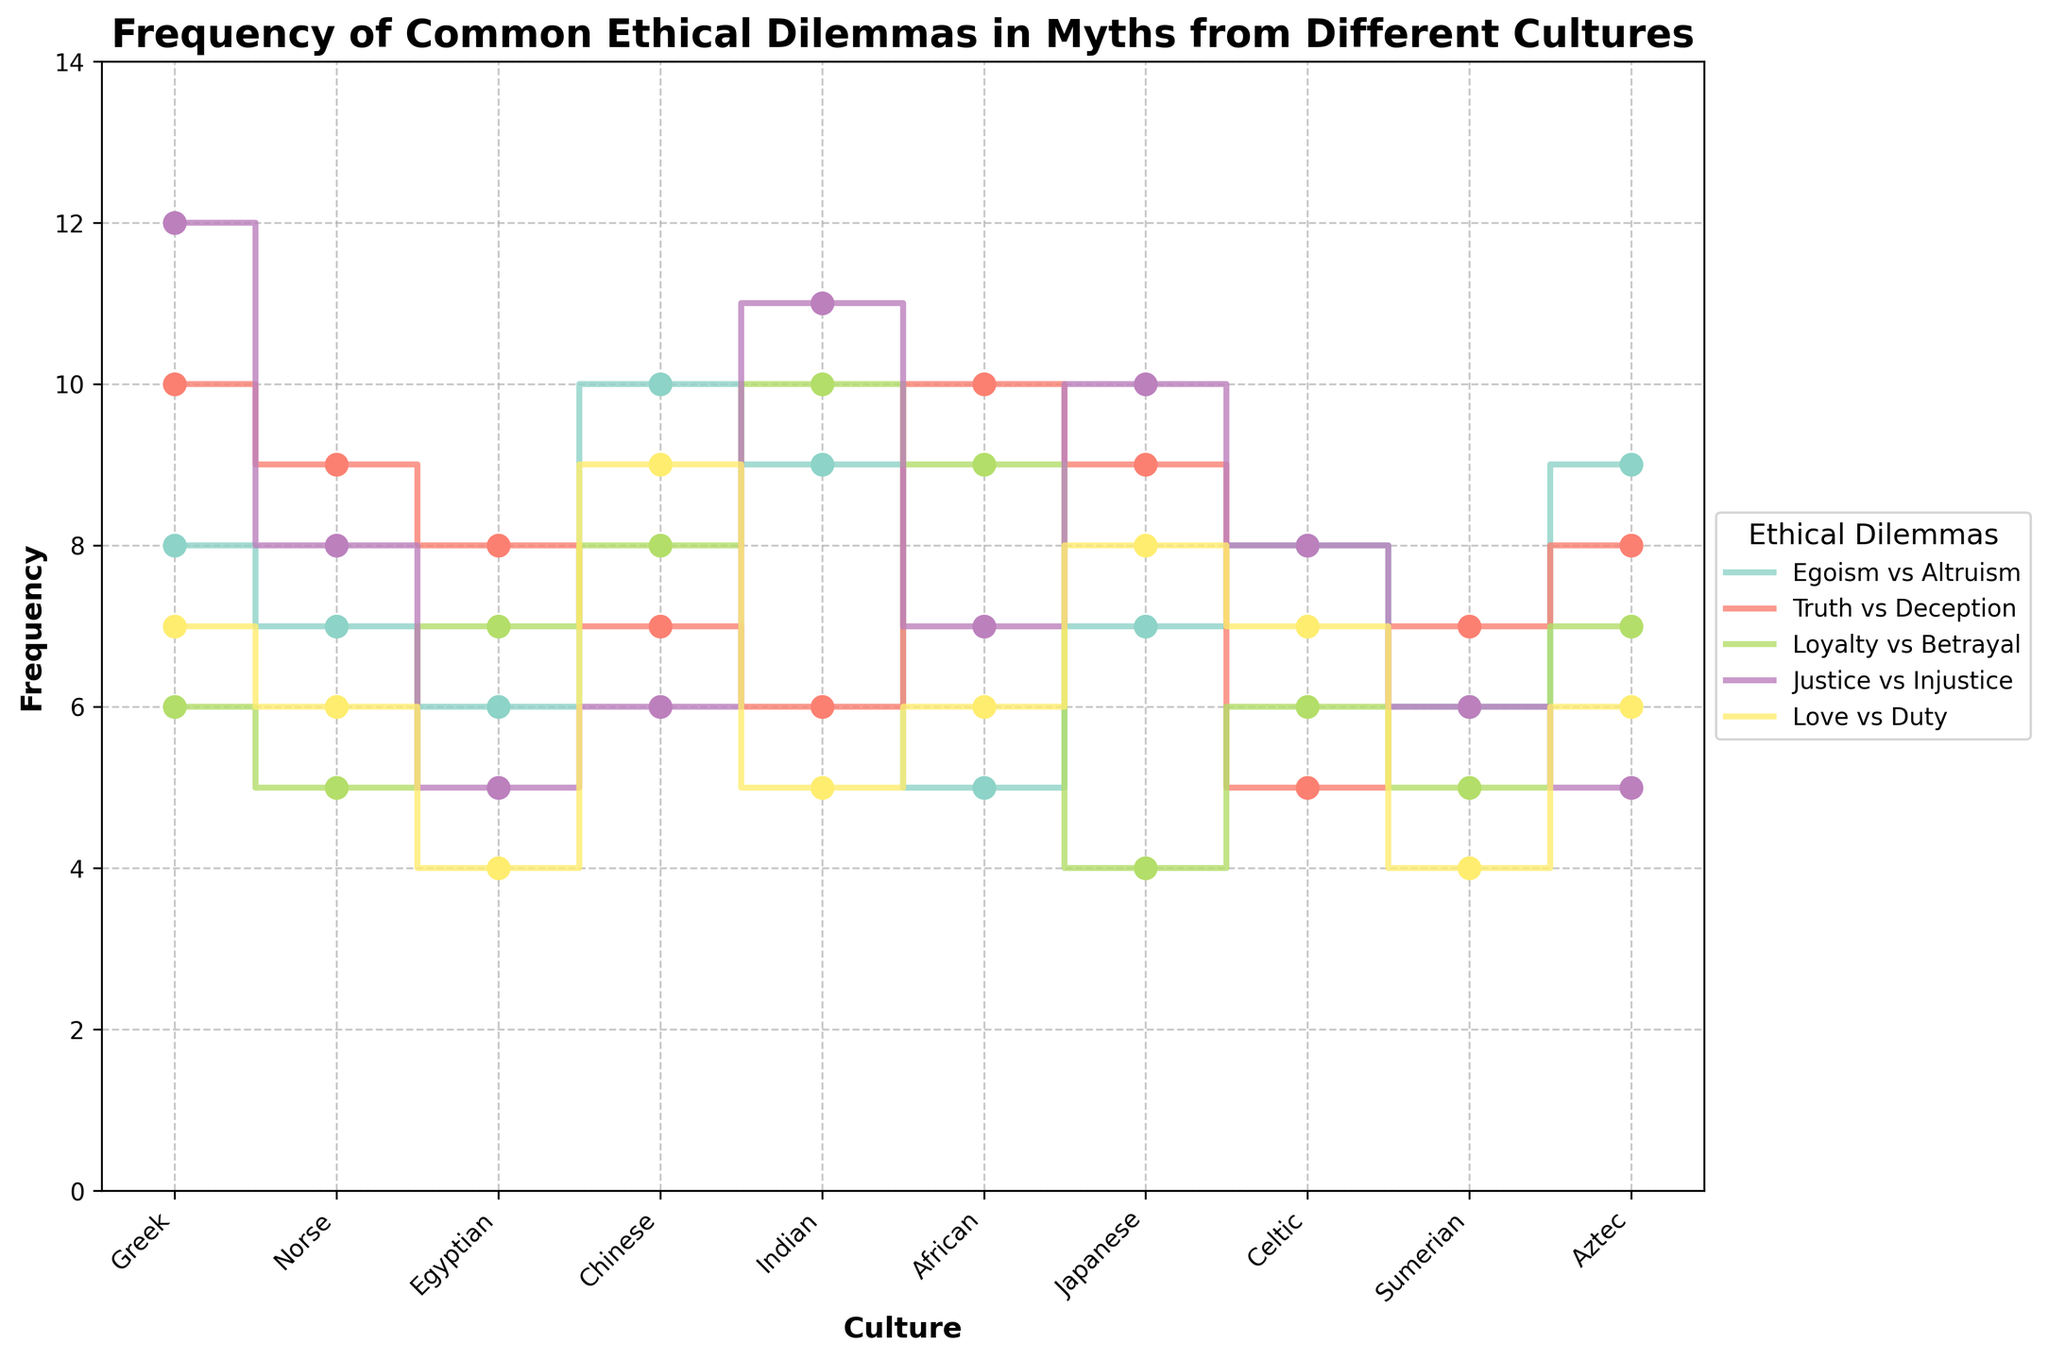What is the title of the figure? The title is written at the top of the figure. It summarizes the content and context of the data being visualized.
Answer: Frequency of Common Ethical Dilemmas in Myths from Different Cultures Which culture has the highest frequency of the "Justice vs Injustice" dilemma? Identify the highest point in the "Justice vs Injustice" (blue line) and note the corresponding culture on the x-axis. The highest frequency is at Greek culture.
Answer: Greek How many ethical dilemmas are plotted in the figure? There are distinct colored lines for each ethical dilemma, and each one is labeled. Count the different labels.
Answer: 5 What is the total frequency of all dilemmas for the Chinese culture? Sum the frequencies of all dilemmas for the Chinese culture: Egoism vs Altruism (10), Truth vs Deception (7), Loyalty vs Betrayal (8), Justice vs Injustice (6), Love vs Duty (9). 10+7+8+6+9 = 40.
Answer: 40 Which dilemma appears least frequently in Egyptian myths? Identify the lowest point among all the dilemmas for Egyptian culture. "Love vs Duty" (red line) has the lowest value.
Answer: Love vs Duty Of the Indian myths, which ethical dilemma has the highest frequency? Identify the highest point among all the dilemmas for Indian culture. "Loyalty vs Betrayal" (dark blue line) has the highest value.
Answer: Loyalty vs Betrayal Compare the frequency of "Loyalty vs Betrayal" between African and Norse cultures. Which one is higher? Locate the "Loyalty vs Betrayal" frequencies for both African and Norse cultures. African frequency is 9 while Norse frequency is 5. African is higher.
Answer: African What is the range of frequencies for the "Truth vs Deception" dilemma across all cultures? Identify the minimum and maximum frequencies for "Truth vs Deception" and find the difference. Minimum is 5 (Celtic), maximum is 10 (Greek and African), hence range is 10-5 = 5.
Answer: 5 Which culture has the most balanced frequency distribution across all dilemmas? Compare the variation in frequencies for each culture. The culture with the smallest range between its highest and lowest dilemma frequency is considered most balanced. For Sumerian: max 7 (Truth vs Deception), min 4 (Love vs Duty), range is 3.
Answer: Sumerian In Japanese myths, how much more frequent is "Justice vs Injustice" compared to "Loyalty vs Betrayal"? Subtract the frequency of "Loyalty vs Betrayal" from "Justice vs Injustice" for Japanese culture. "Justice vs Injustice" is 10, "Loyalty vs Betrayal" is 4, hence 10-4=6.
Answer: 6 